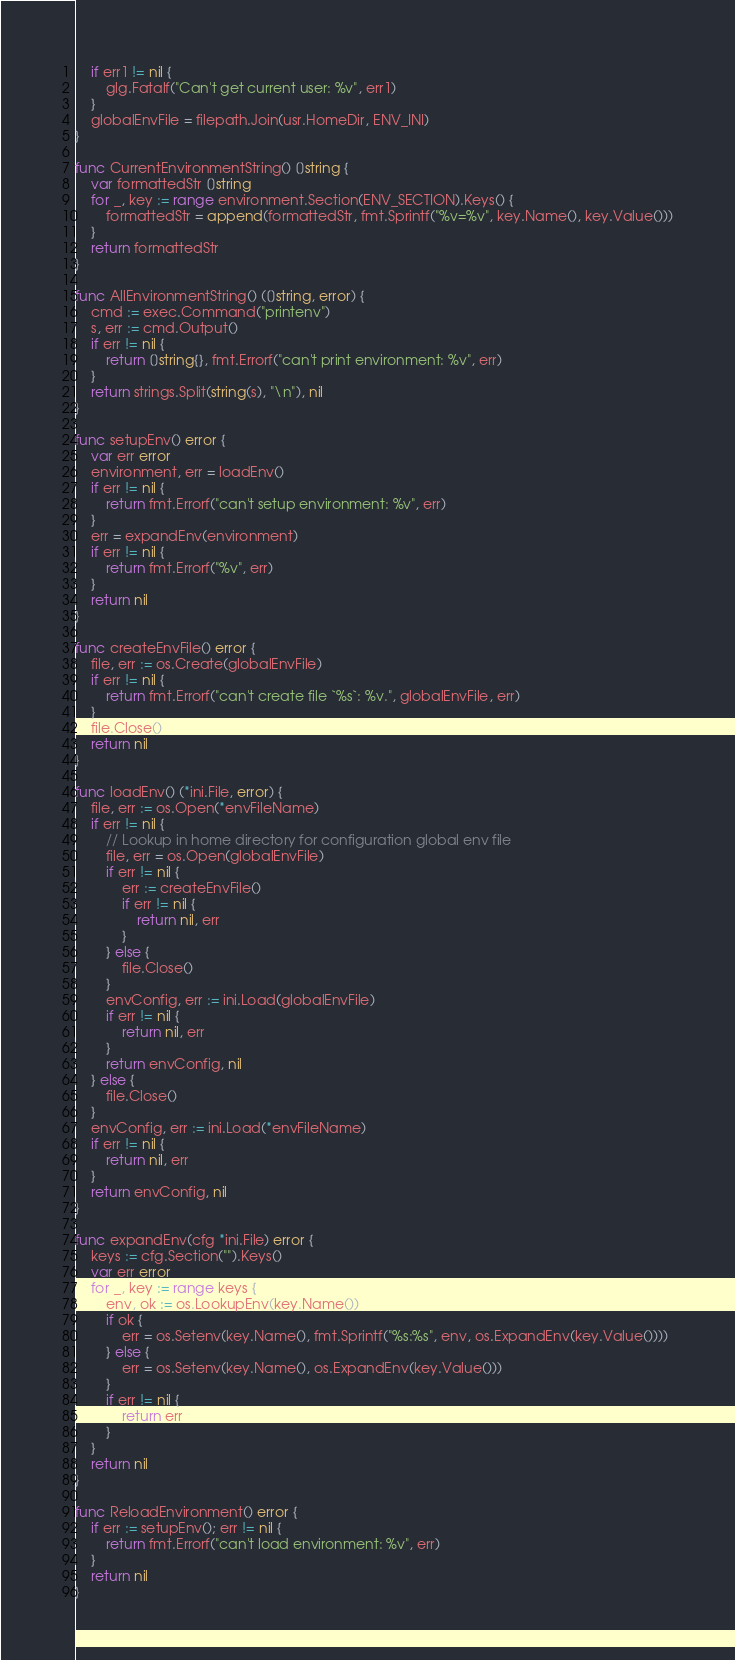Convert code to text. <code><loc_0><loc_0><loc_500><loc_500><_Go_>	if err1 != nil {
		glg.Fatalf("Can't get current user: %v", err1)
	}
	globalEnvFile = filepath.Join(usr.HomeDir, ENV_INI)
}

func CurrentEnvironmentString() []string {
	var formattedStr []string
	for _, key := range environment.Section(ENV_SECTION).Keys() {
		formattedStr = append(formattedStr, fmt.Sprintf("%v=%v", key.Name(), key.Value()))
	}
	return formattedStr
}

func AllEnvironmentString() ([]string, error) {
	cmd := exec.Command("printenv")
	s, err := cmd.Output()
	if err != nil {
		return []string{}, fmt.Errorf("can't print environment: %v", err)
	}
	return strings.Split(string(s), "\n"), nil
}

func setupEnv() error {
	var err error
	environment, err = loadEnv()
	if err != nil {
		return fmt.Errorf("can't setup environment: %v", err)
	}
	err = expandEnv(environment)
	if err != nil {
		return fmt.Errorf("%v", err)
	}
	return nil
}

func createEnvFile() error {
	file, err := os.Create(globalEnvFile)
	if err != nil {
		return fmt.Errorf("can't create file `%s`: %v.", globalEnvFile, err)
	}
	file.Close()
	return nil
}

func loadEnv() (*ini.File, error) {
	file, err := os.Open(*envFileName)
	if err != nil {
		// Lookup in home directory for configuration global env file
		file, err = os.Open(globalEnvFile)
		if err != nil {
			err := createEnvFile()
			if err != nil {
				return nil, err
			}
		} else {
			file.Close()
		}
		envConfig, err := ini.Load(globalEnvFile)
		if err != nil {
			return nil, err
		}
		return envConfig, nil
	} else {
		file.Close()
	}
	envConfig, err := ini.Load(*envFileName)
	if err != nil {
		return nil, err
	}
	return envConfig, nil
}

func expandEnv(cfg *ini.File) error {
	keys := cfg.Section("").Keys()
	var err error
	for _, key := range keys {
		env, ok := os.LookupEnv(key.Name())
		if ok {
			err = os.Setenv(key.Name(), fmt.Sprintf("%s:%s", env, os.ExpandEnv(key.Value())))
		} else {
			err = os.Setenv(key.Name(), os.ExpandEnv(key.Value()))
		}
		if err != nil {
			return err
		}
	}
	return nil
}

func ReloadEnvironment() error {
	if err := setupEnv(); err != nil {
		return fmt.Errorf("can't load environment: %v", err)
	}
	return nil
}
</code> 